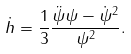<formula> <loc_0><loc_0><loc_500><loc_500>\dot { h } = \frac { 1 } { 3 } \frac { \ddot { \psi } \psi - \dot { \psi } ^ { 2 } } { \psi ^ { 2 } } .</formula> 